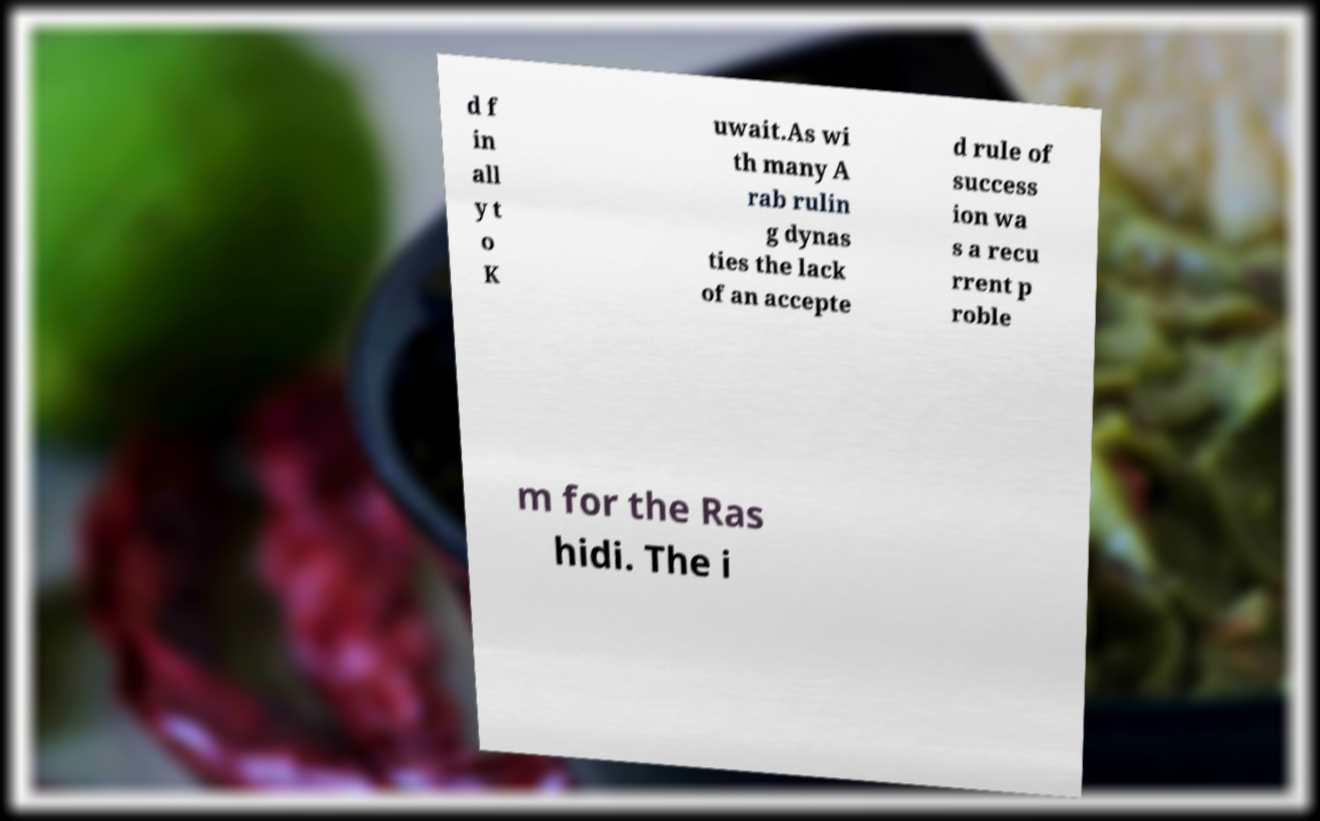Could you assist in decoding the text presented in this image and type it out clearly? d f in all y t o K uwait.As wi th many A rab rulin g dynas ties the lack of an accepte d rule of success ion wa s a recu rrent p roble m for the Ras hidi. The i 